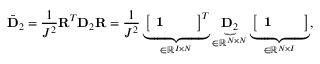<formula> <loc_0><loc_0><loc_500><loc_500>\bar { D } _ { 2 } = \frac { 1 } { J ^ { 2 } } R ^ { T } D _ { 2 } R = \frac { 1 } { J ^ { 2 } } \underbrace { \left [ \begin{array} { l l l } { 1 } \end{array} \right ] ^ { T } } _ { \in \mathbb { R } ^ { I \times N } } \underbrace { D _ { 2 } } _ { \in \mathbb { R } ^ { N \times N } } \underbrace { \left [ \begin{array} { l l l } { 1 } \end{array} \right ] } _ { \in \mathbb { R } ^ { N \times I } } ,</formula> 